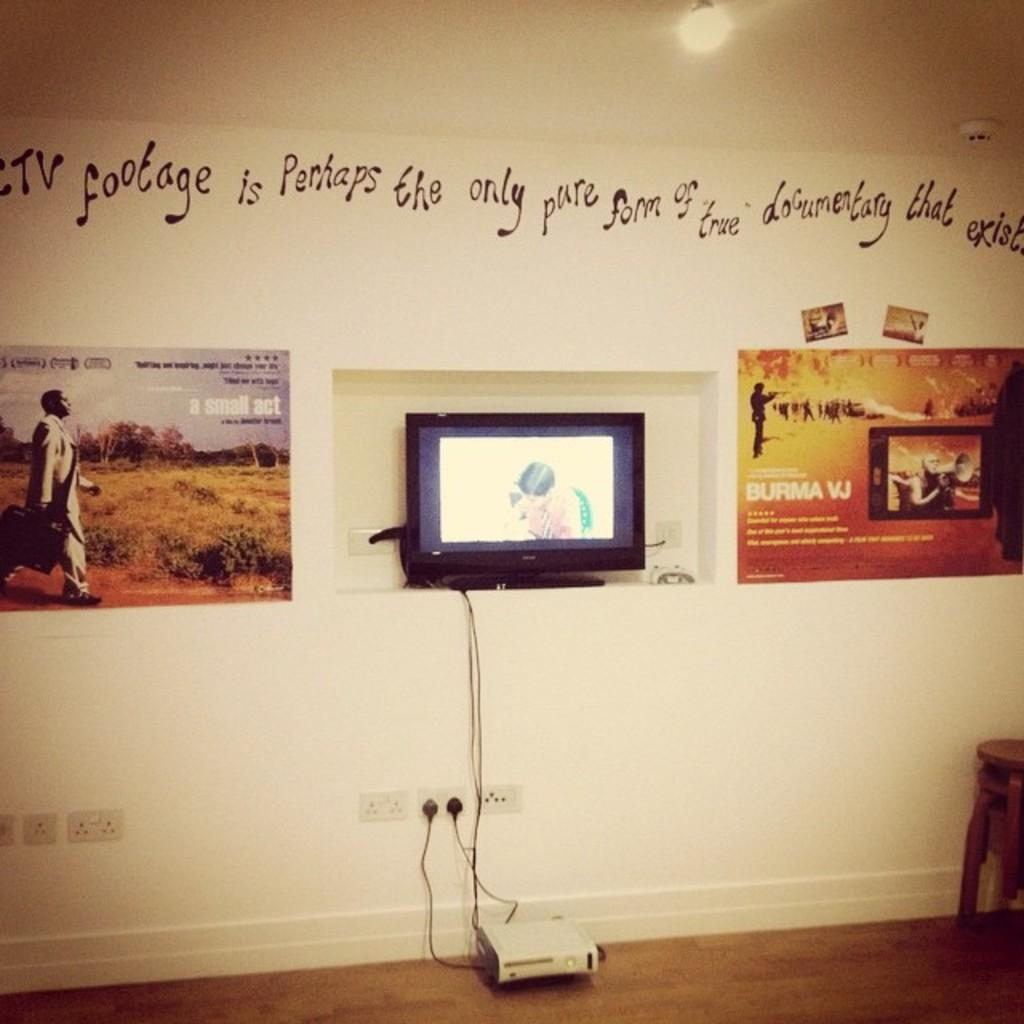Provide a one-sentence caption for the provided image. A bright-colored banner describes something called "Burma VJ.". 